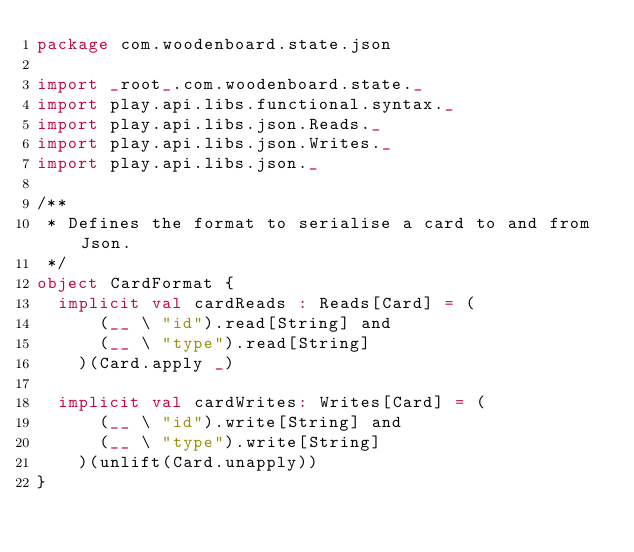<code> <loc_0><loc_0><loc_500><loc_500><_Scala_>package com.woodenboard.state.json

import _root_.com.woodenboard.state._
import play.api.libs.functional.syntax._
import play.api.libs.json.Reads._
import play.api.libs.json.Writes._
import play.api.libs.json._

/**
 * Defines the format to serialise a card to and from Json.
 */
object CardFormat {
  implicit val cardReads : Reads[Card] = (
      (__ \ "id").read[String] and
      (__ \ "type").read[String]
    )(Card.apply _)

  implicit val cardWrites: Writes[Card] = (
      (__ \ "id").write[String] and
      (__ \ "type").write[String]
    )(unlift(Card.unapply))
}
</code> 